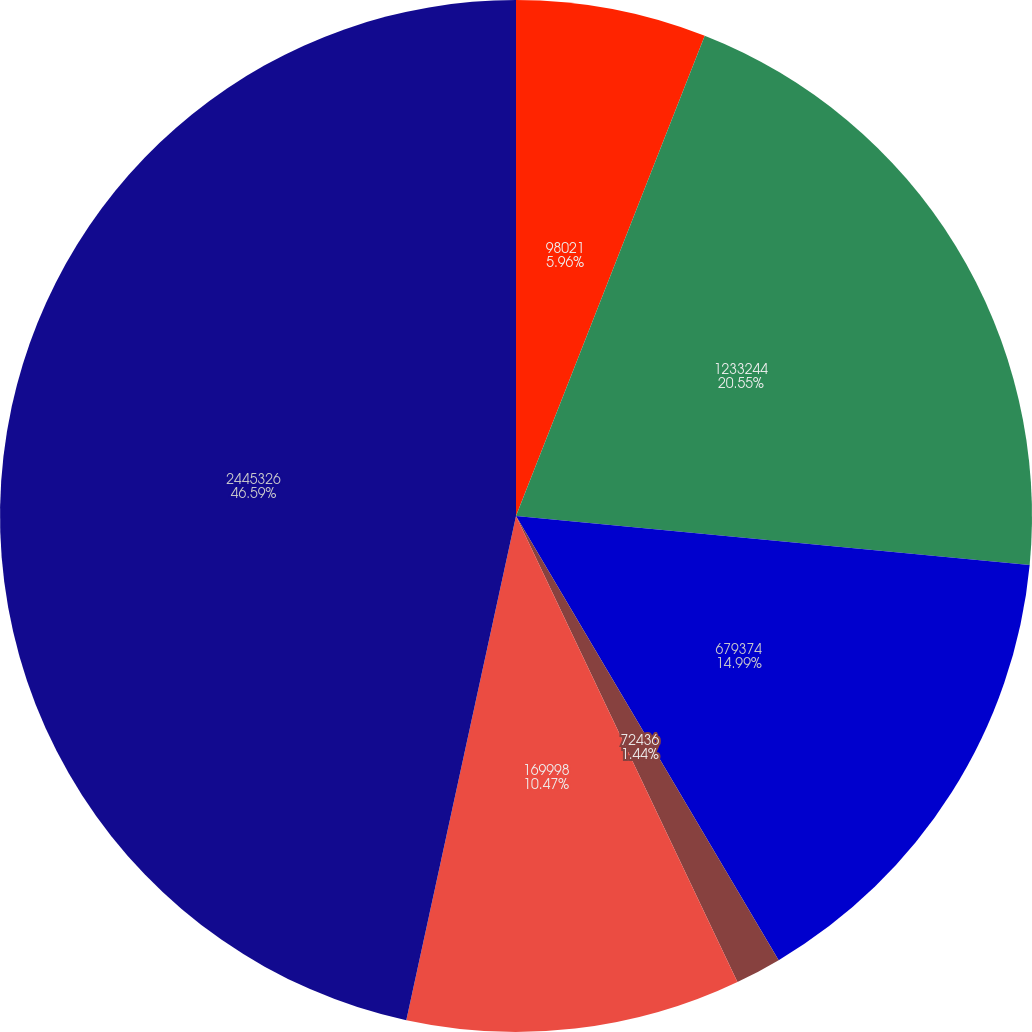Convert chart. <chart><loc_0><loc_0><loc_500><loc_500><pie_chart><fcel>98021<fcel>1233244<fcel>679374<fcel>72436<fcel>169998<fcel>2445326<nl><fcel>5.96%<fcel>20.55%<fcel>14.99%<fcel>1.44%<fcel>10.47%<fcel>46.59%<nl></chart> 